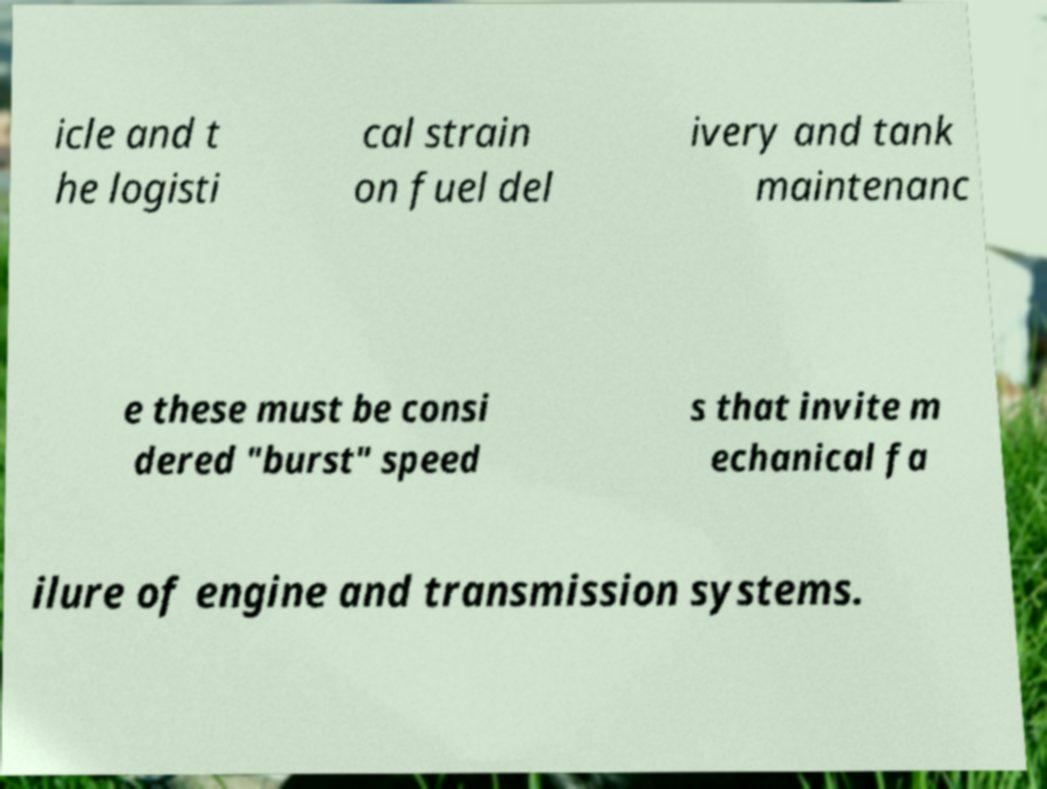What messages or text are displayed in this image? I need them in a readable, typed format. icle and t he logisti cal strain on fuel del ivery and tank maintenanc e these must be consi dered "burst" speed s that invite m echanical fa ilure of engine and transmission systems. 